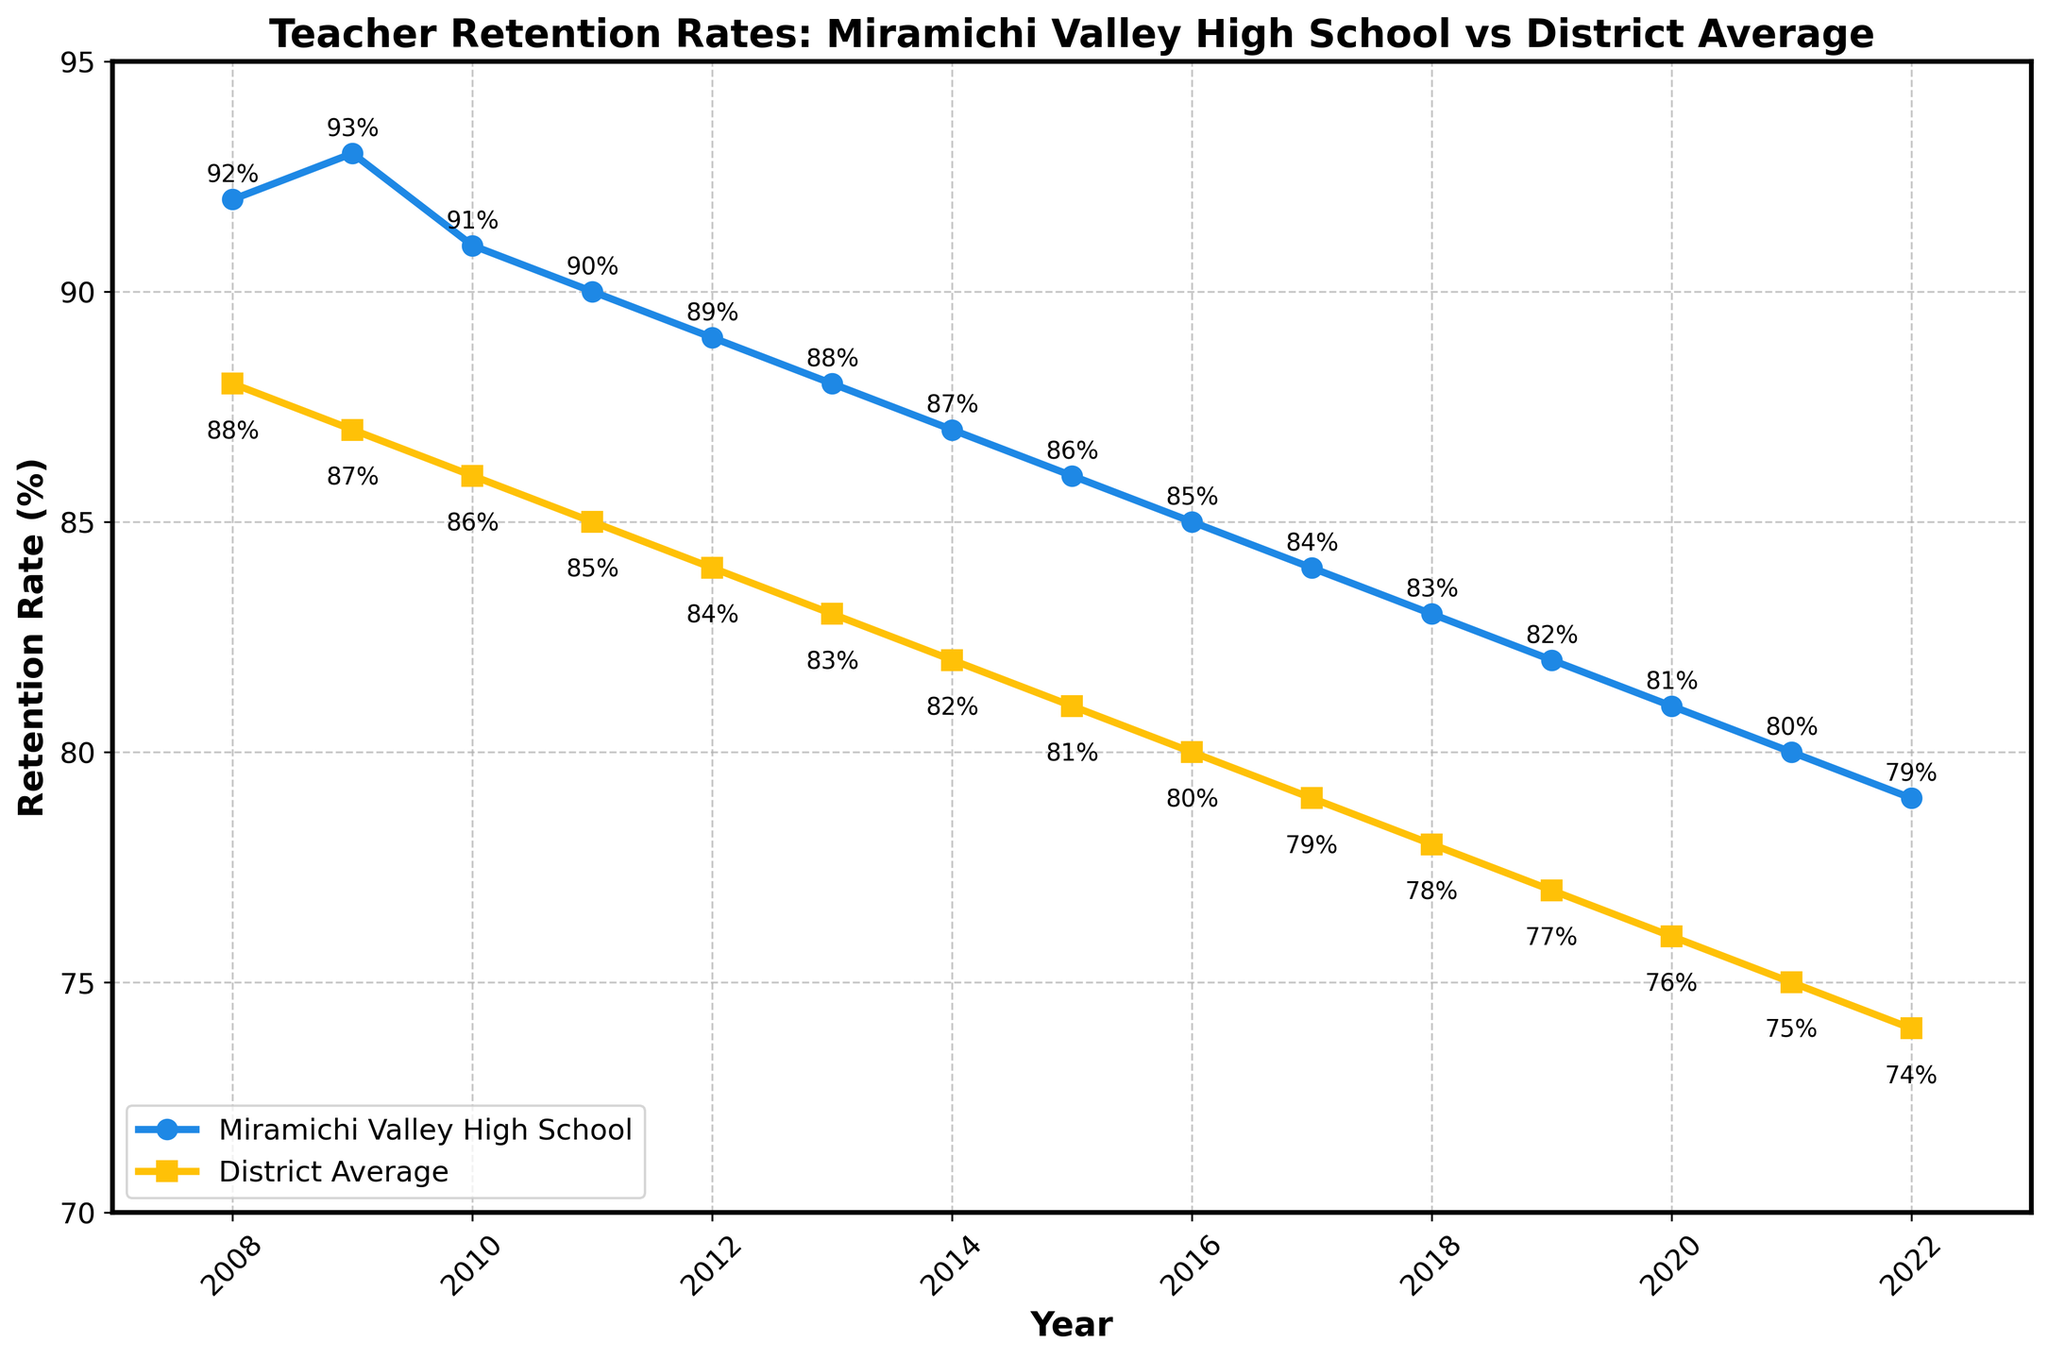What's the overall trend of teacher retention rates at Miramichi Valley High School from 2008 to 2022? The trend shows a continuous decline in teacher retention rates over the 15-year period.
Answer: Continuous decline How does the teacher retention rate at Miramichi Valley High School in 2022 compare with the district average in the same year? In 2022, the teacher retention rate at Miramichi Valley High School is 79%, while the district average is 74%. Therefore, Miramichi Valley High School’s rate is higher by 5%.
Answer: Miramichi Valley is higher by 5% Which year had the highest teacher retention rate at Miramichi Valley High School and what was the rate? The highest teacher retention rate at Miramichi Valley High School was in 2009, with a rate of 93%.
Answer: 2009, 93% Compare the rate decreases from 2008 to 2022 between Miramichi Valley High School and the district average. Miramichi Valley High School's rate decreased from 92% in 2008 to 79% in 2022, a 13% drop. The district average decreased from 88% in 2008 to 74% in 2022, a 14% drop. Hence, the district average experienced a larger decrease by 1%.
Answer: District average decreased more by 1% Identify the years when the teacher retention rate of Miramichi Valley High School was exactly 1% higher than the district average. In 2009, the retention rate at Miramichi Valley High School was 93% and the district average was 87%, a difference of 1%. In 2012, MVHS had a rate of 89% compared to the district's 84%, again a 1% difference.
Answer: 2009, 2012 What is the average teacher retention rate at Miramichi Valley High School for the years 2008-2012? The rates for the years 2008-2012 are 92, 93, 91, 90, and 89. Summing these up gives 455. Dividing by 5 (number of years) gives an average retention rate of 91%.
Answer: 91% By how much did the teacher retention rate decrease between 2009 and 2013 at Miramichi Valley High School, and was this greater than the district average for the same period? In 2009, the rate was 93%, and in 2013, it was 88%, a drop of 5%. For the district, the rates were 87% in 2009 and 83% in 2013, a drop of 4%. Therefore, the decrease at Miramichi Valley High School was greater by 1%.
Answer: Miramichi Valley decreased more by 1% What are the colors representing Miramichi Valley High School and the district average in the plot, respectively? The plot uses blue for Miramichi Valley High School and yellow for the district average.
Answer: Blue, Yellow During which years did the teacher retention rate at Miramichi Valley High School fall below 85%? The retention rate fell below 85% starting from 2016 onwards: 2016 (85%), 2017 (84%), 2018 (83%), 2019 (82%), 2020 (81%), 2021 (80%), and 2022 (79%).
Answer: 2016-2022 